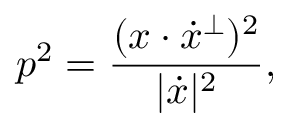Convert formula to latex. <formula><loc_0><loc_0><loc_500><loc_500>p ^ { 2 } = { \frac { ( x \cdot { \dot { x } } ^ { \perp } ) ^ { 2 } } { | { \dot { x } } | ^ { 2 } } } ,</formula> 